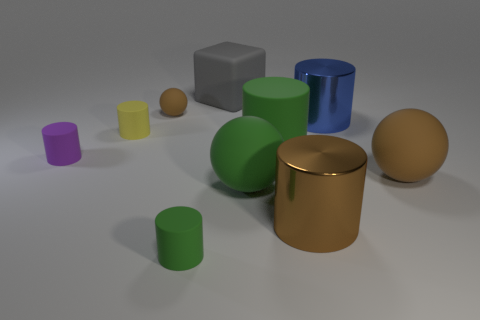Subtract all brown rubber balls. How many balls are left? 1 Subtract all brown spheres. How many spheres are left? 1 Subtract all cubes. How many objects are left? 9 Add 4 large blue cylinders. How many large blue cylinders are left? 5 Add 8 tiny purple rubber things. How many tiny purple rubber things exist? 9 Subtract 0 blue cubes. How many objects are left? 10 Subtract 1 balls. How many balls are left? 2 Subtract all yellow spheres. Subtract all blue cylinders. How many spheres are left? 3 Subtract all yellow balls. How many green cylinders are left? 2 Subtract all green spheres. Subtract all large blue shiny cylinders. How many objects are left? 8 